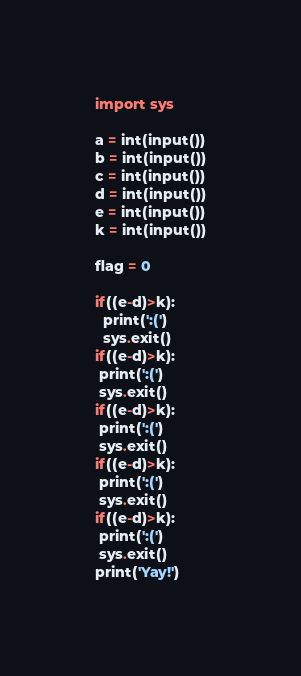Convert code to text. <code><loc_0><loc_0><loc_500><loc_500><_Python_>import sys

a = int(input())
b = int(input())
c = int(input())
d = int(input())
e = int(input())
k = int(input())

flag = 0

if((e-d)>k):
  print(':(')
  sys.exit()
if((e-d)>k):
 print(':(')
 sys.exit()
if((e-d)>k):
 print(':(')
 sys.exit()
if((e-d)>k):
 print(':(')
 sys.exit()
if((e-d)>k):
 print(':(')
 sys.exit()
print('Yay!')</code> 